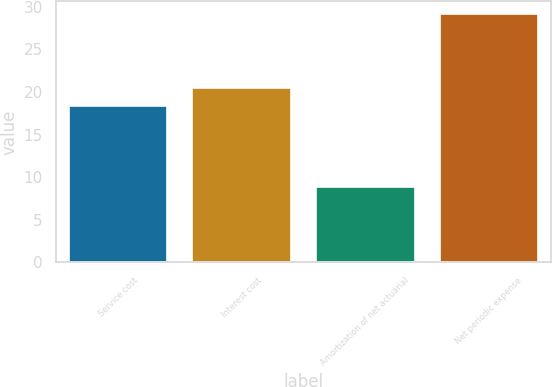<chart> <loc_0><loc_0><loc_500><loc_500><bar_chart><fcel>Service cost<fcel>Interest cost<fcel>Amortization of net actuarial<fcel>Net periodic expense<nl><fcel>18.4<fcel>20.44<fcel>8.8<fcel>29.2<nl></chart> 